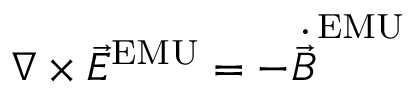Convert formula to latex. <formula><loc_0><loc_0><loc_500><loc_500>\nabla \times { \vec { E } } ^ { E M U } = - { \dot { \vec { B } } } ^ { E M U }</formula> 